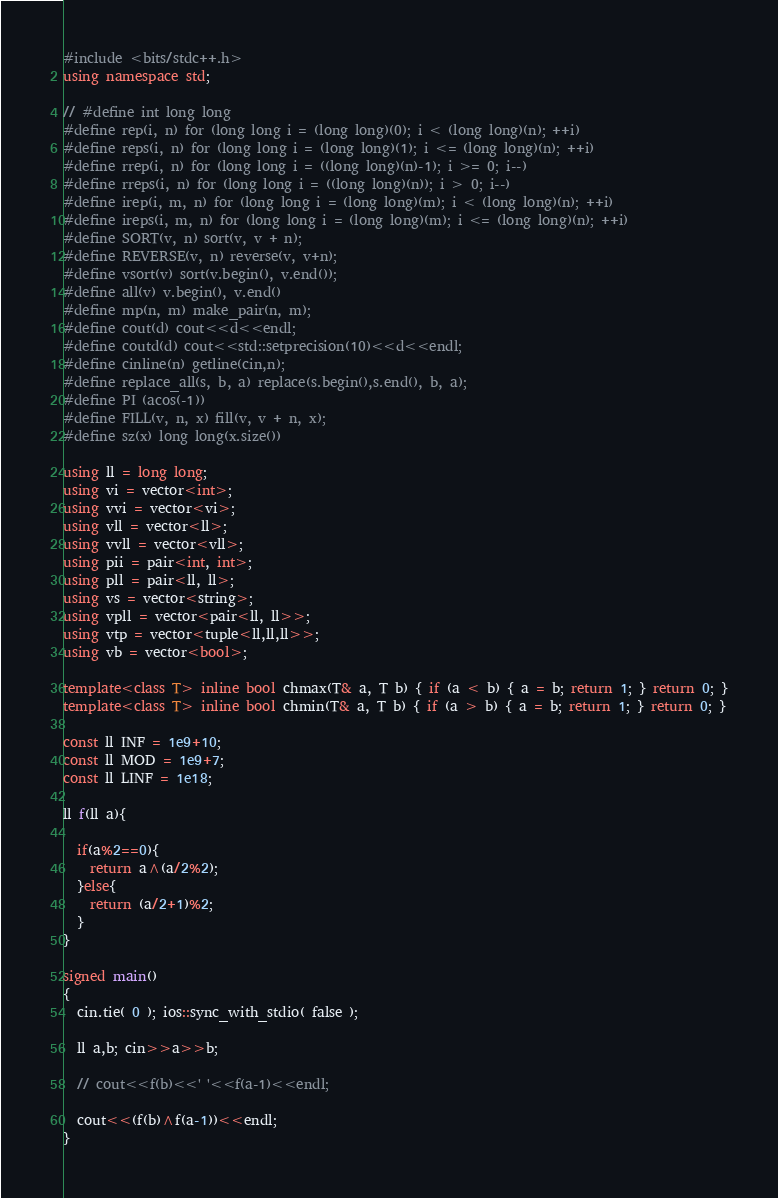<code> <loc_0><loc_0><loc_500><loc_500><_C++_>#include <bits/stdc++.h>
using namespace std;

// #define int long long
#define rep(i, n) for (long long i = (long long)(0); i < (long long)(n); ++i)
#define reps(i, n) for (long long i = (long long)(1); i <= (long long)(n); ++i)
#define rrep(i, n) for (long long i = ((long long)(n)-1); i >= 0; i--)
#define rreps(i, n) for (long long i = ((long long)(n)); i > 0; i--)
#define irep(i, m, n) for (long long i = (long long)(m); i < (long long)(n); ++i)
#define ireps(i, m, n) for (long long i = (long long)(m); i <= (long long)(n); ++i)
#define SORT(v, n) sort(v, v + n);
#define REVERSE(v, n) reverse(v, v+n);
#define vsort(v) sort(v.begin(), v.end());
#define all(v) v.begin(), v.end()
#define mp(n, m) make_pair(n, m);
#define cout(d) cout<<d<<endl;
#define coutd(d) cout<<std::setprecision(10)<<d<<endl;
#define cinline(n) getline(cin,n);
#define replace_all(s, b, a) replace(s.begin(),s.end(), b, a);
#define PI (acos(-1))
#define FILL(v, n, x) fill(v, v + n, x);
#define sz(x) long long(x.size())

using ll = long long;
using vi = vector<int>;
using vvi = vector<vi>;
using vll = vector<ll>;
using vvll = vector<vll>;
using pii = pair<int, int>;
using pll = pair<ll, ll>;
using vs = vector<string>;
using vpll = vector<pair<ll, ll>>;
using vtp = vector<tuple<ll,ll,ll>>;
using vb = vector<bool>;

template<class T> inline bool chmax(T& a, T b) { if (a < b) { a = b; return 1; } return 0; }
template<class T> inline bool chmin(T& a, T b) { if (a > b) { a = b; return 1; } return 0; }

const ll INF = 1e9+10;
const ll MOD = 1e9+7;
const ll LINF = 1e18;

ll f(ll a){
  
  if(a%2==0){
    return a^(a/2%2);
  }else{
    return (a/2+1)%2;
  }
}

signed main()
{
  cin.tie( 0 ); ios::sync_with_stdio( false );
  
  ll a,b; cin>>a>>b;
  
  // cout<<f(b)<<' '<<f(a-1)<<endl;
  
  cout<<(f(b)^f(a-1))<<endl;
}
</code> 